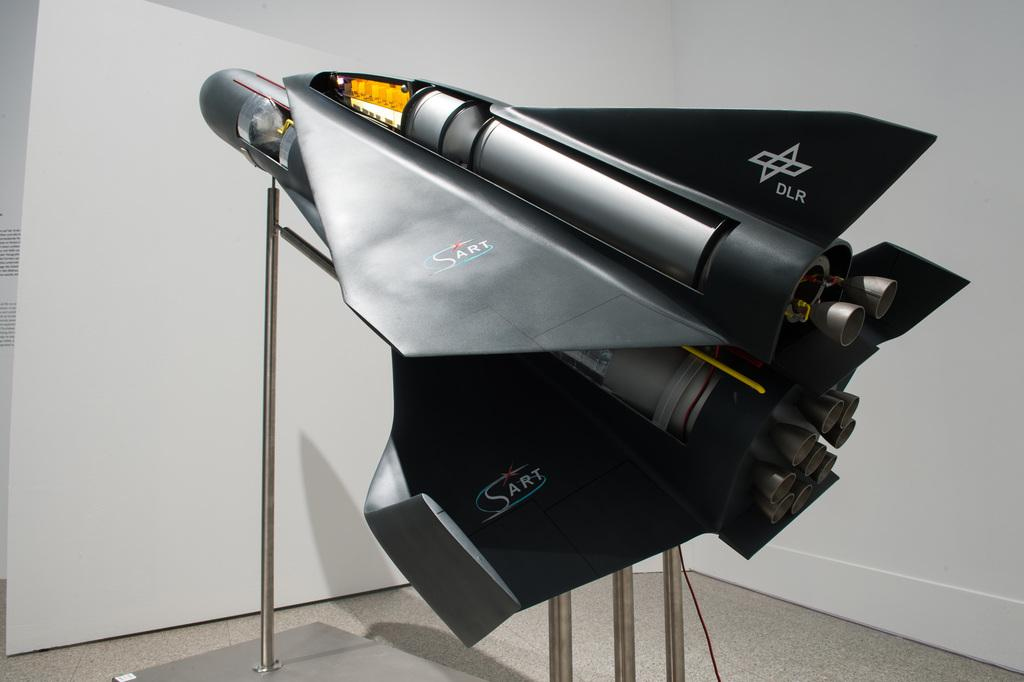Provide a one-sentence caption for the provided image. Black model aircraft with DLR printed on the tail. 